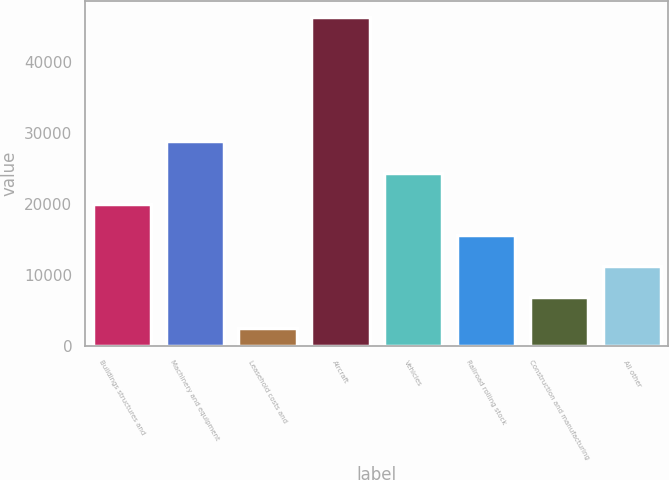Convert chart. <chart><loc_0><loc_0><loc_500><loc_500><bar_chart><fcel>Buildings structures and<fcel>Machinery and equipment<fcel>Leasehold costs and<fcel>Aircraft<fcel>Vehicles<fcel>Railroad rolling stock<fcel>Construction and manufacturing<fcel>All other<nl><fcel>20018.8<fcel>28759.2<fcel>2538<fcel>46240<fcel>24389<fcel>15648.6<fcel>6908.2<fcel>11278.4<nl></chart> 